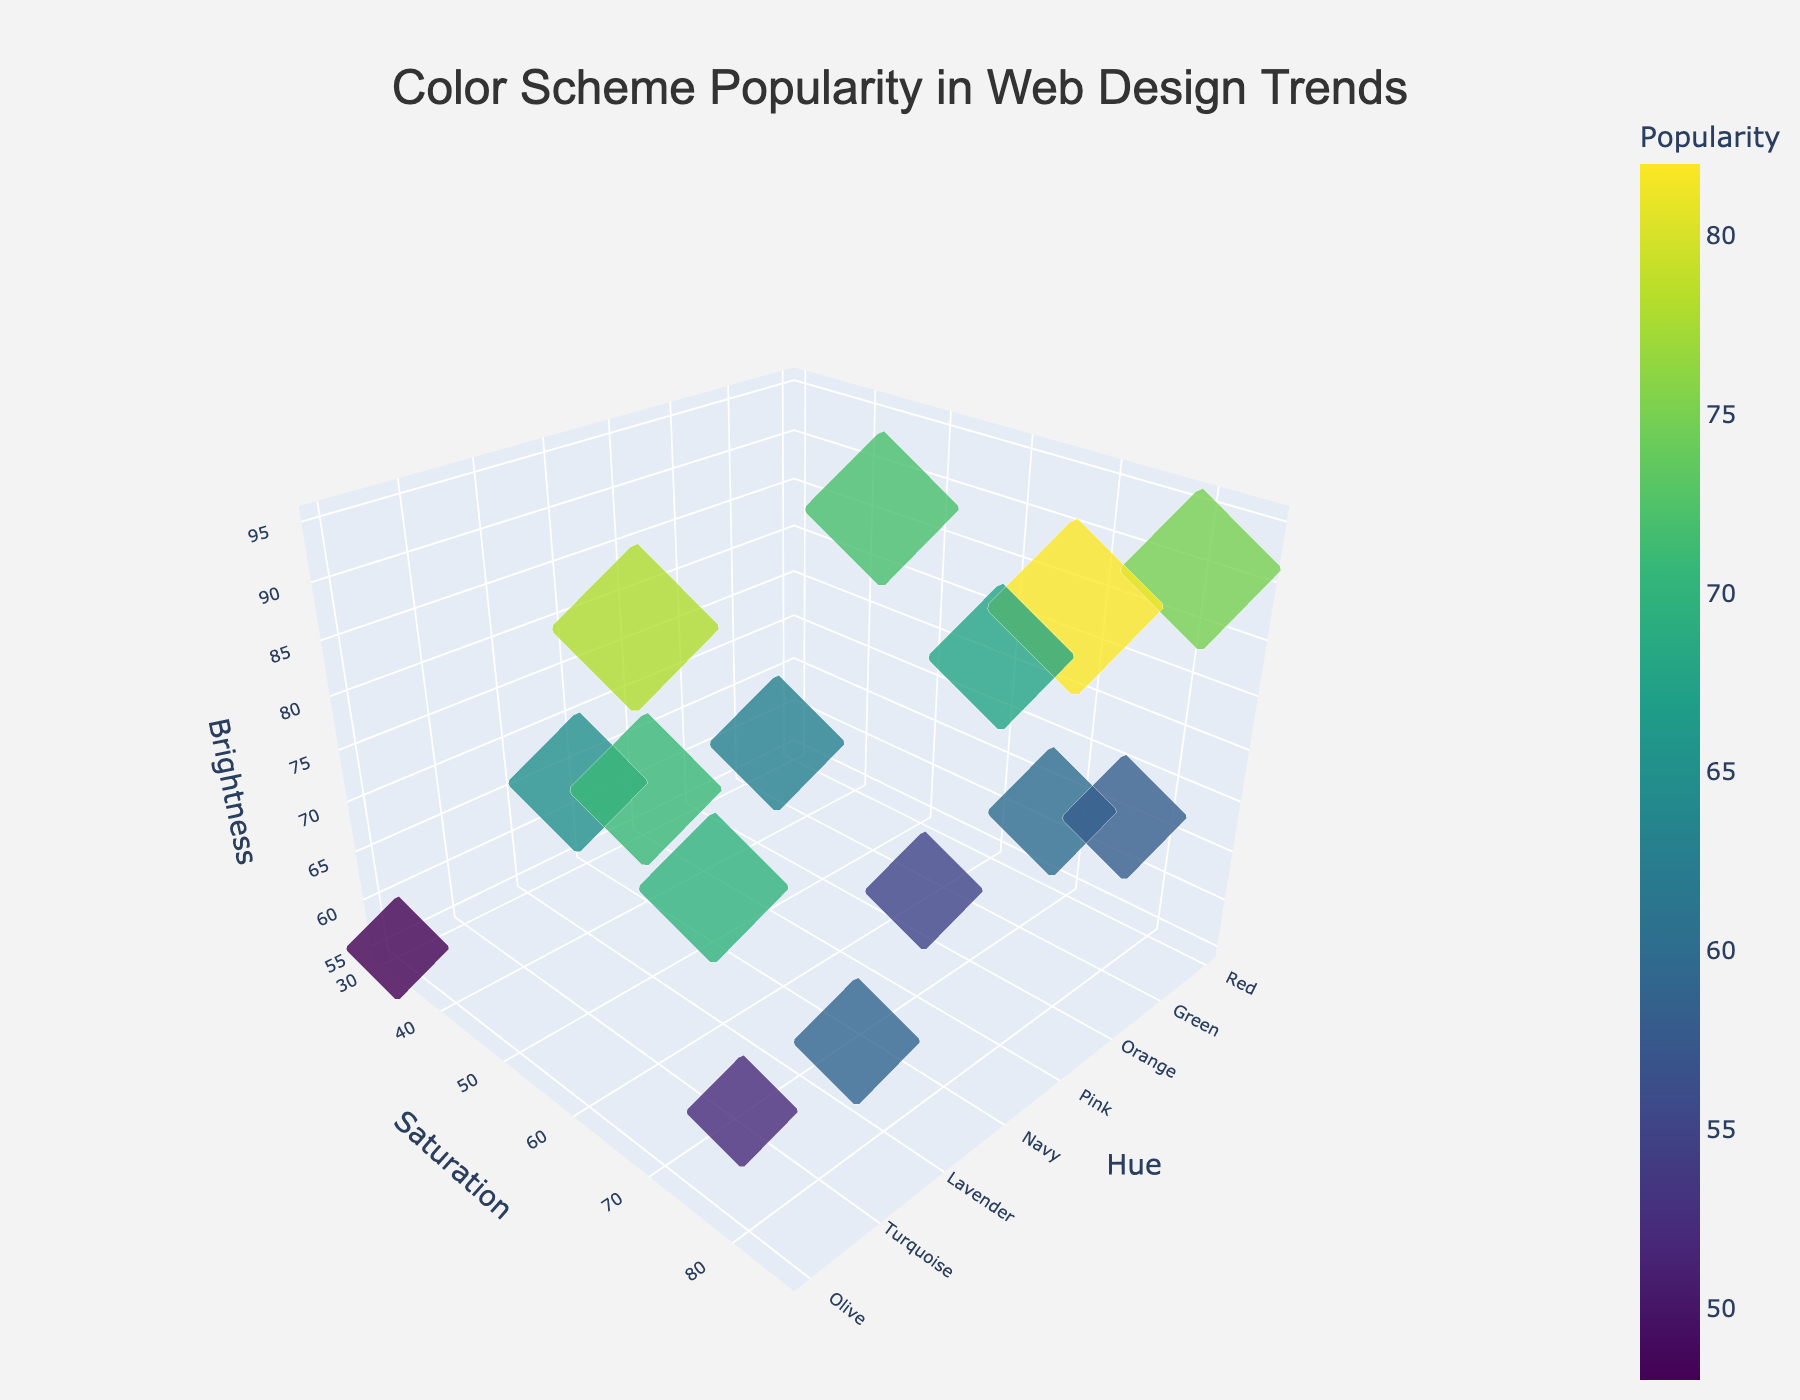What is the title of the figure? The title of the figure is usually displayed at the top and is meant to give a brief summary of what the plot represents. In this case, the title is "Color Scheme Popularity in Web Design Trends".
Answer: Color Scheme Popularity in Web Design Trends How many data points are there in the figure? By looking at the number of markers (points) in the 3D plot, we can count that there are 15 different colors analyzed.
Answer: 15 Which color scheme has the highest popularity? The popularity of each color scheme is indicated by the size and color of the markers. The largest and darkest marker indicates the highest popularity, which corresponds to the Blue color scheme.
Answer: Blue What are the axes labels of the plot? The labels on the x, y, and z axes give the dimensions being used to plot the data: Hue, Saturation, and Brightness, respectively.
Answer: Hue, Saturation, Brightness Which two color schemes have the closest saturation values? By observing the y-axis (Saturation) positions of the markers, Pink and Coral have very close saturation values, both around 65.
Answer: Pink and Coral What is the overall trend in popularity with respect to brightness? Analyzing the z-axis (Brightness) and the size/color of the markers, we generally see that lower brightness values correlate with higher popularity indicators (size/color).
Answer: Decreasing trend What is the average saturation value across all color schemes? To find the average saturation, sum the saturation values and divide by the number of data points. (80+70+65+75+85+60+70+55+50+45+40+80+60+75+30)/15 = 61.3
Answer: 61.3 Which color scheme has the least brightness value? The marker positioned lowest on the z-axis (Brightness) indicates the least brightness value, which corresponds to the Olive color scheme.
Answer: Olive Compare the popularity of Red and Yellow color schemes. Which one is more popular? By comparing the size and color of the markers for Red and Yellow, we see that the Red marker is larger and darker, indicating it is more popular than Yellow.
Answer: Red What is the range of hue values in the plot? To find the range, identify the minimum and maximum hue values from all color schemes. The minimum is Olive (30) and the maximum is Orange (85), so the range is 85-30=55.
Answer: 55 